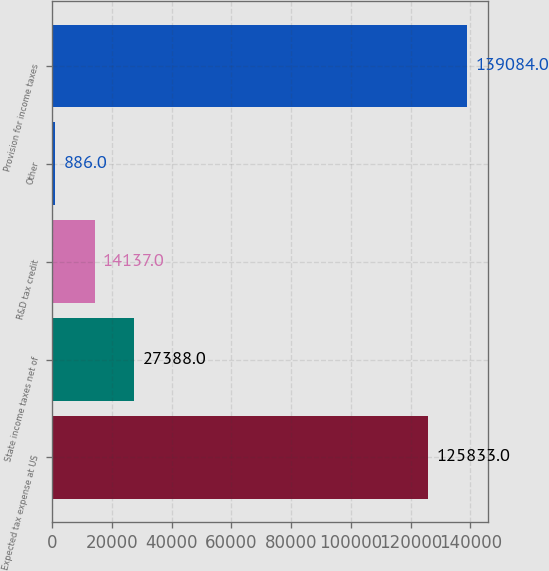<chart> <loc_0><loc_0><loc_500><loc_500><bar_chart><fcel>Expected tax expense at US<fcel>State income taxes net of<fcel>R&D tax credit<fcel>Other<fcel>Provision for income taxes<nl><fcel>125833<fcel>27388<fcel>14137<fcel>886<fcel>139084<nl></chart> 